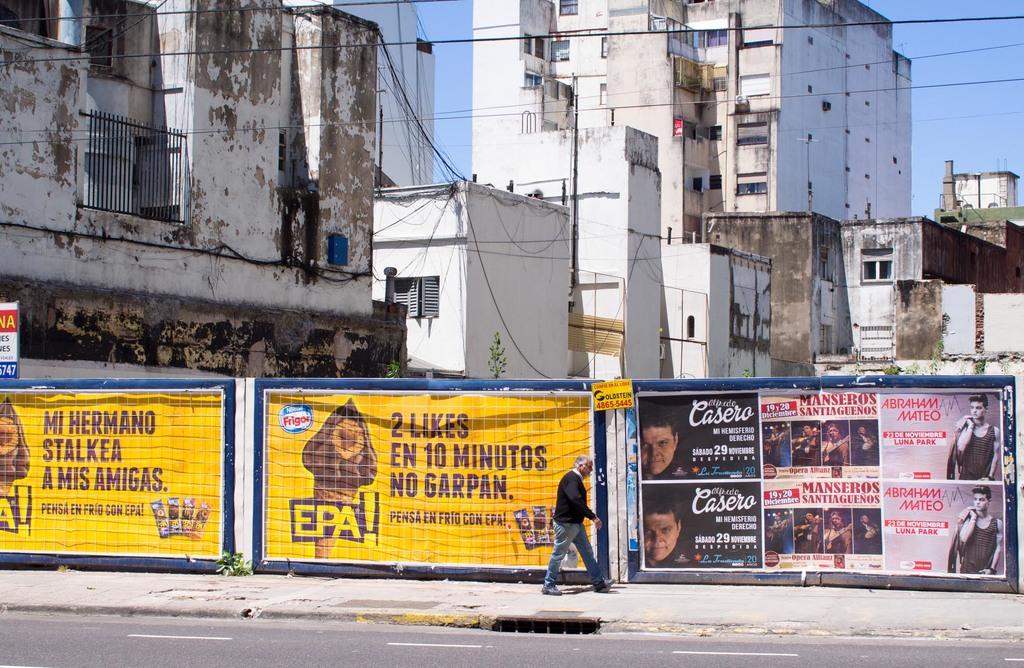How many minutes does it take?
Keep it short and to the point. 10. 